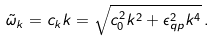<formula> <loc_0><loc_0><loc_500><loc_500>\tilde { \omega } _ { k } = c _ { k } k = \sqrt { c _ { 0 } ^ { 2 } k ^ { 2 } + \epsilon _ { q p } ^ { 2 } k ^ { 4 } } \, .</formula> 